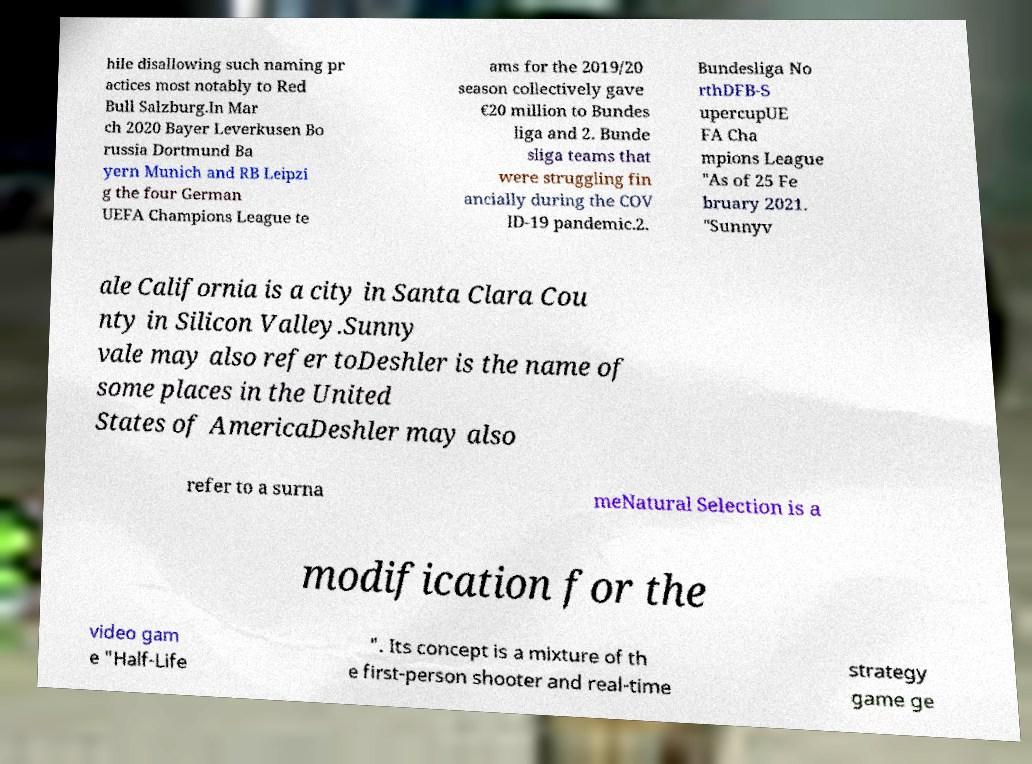Could you assist in decoding the text presented in this image and type it out clearly? hile disallowing such naming pr actices most notably to Red Bull Salzburg.In Mar ch 2020 Bayer Leverkusen Bo russia Dortmund Ba yern Munich and RB Leipzi g the four German UEFA Champions League te ams for the 2019/20 season collectively gave €20 million to Bundes liga and 2. Bunde sliga teams that were struggling fin ancially during the COV ID-19 pandemic.2. Bundesliga No rthDFB-S upercupUE FA Cha mpions League "As of 25 Fe bruary 2021. "Sunnyv ale California is a city in Santa Clara Cou nty in Silicon Valley.Sunny vale may also refer toDeshler is the name of some places in the United States of AmericaDeshler may also refer to a surna meNatural Selection is a modification for the video gam e "Half-Life ". Its concept is a mixture of th e first-person shooter and real-time strategy game ge 